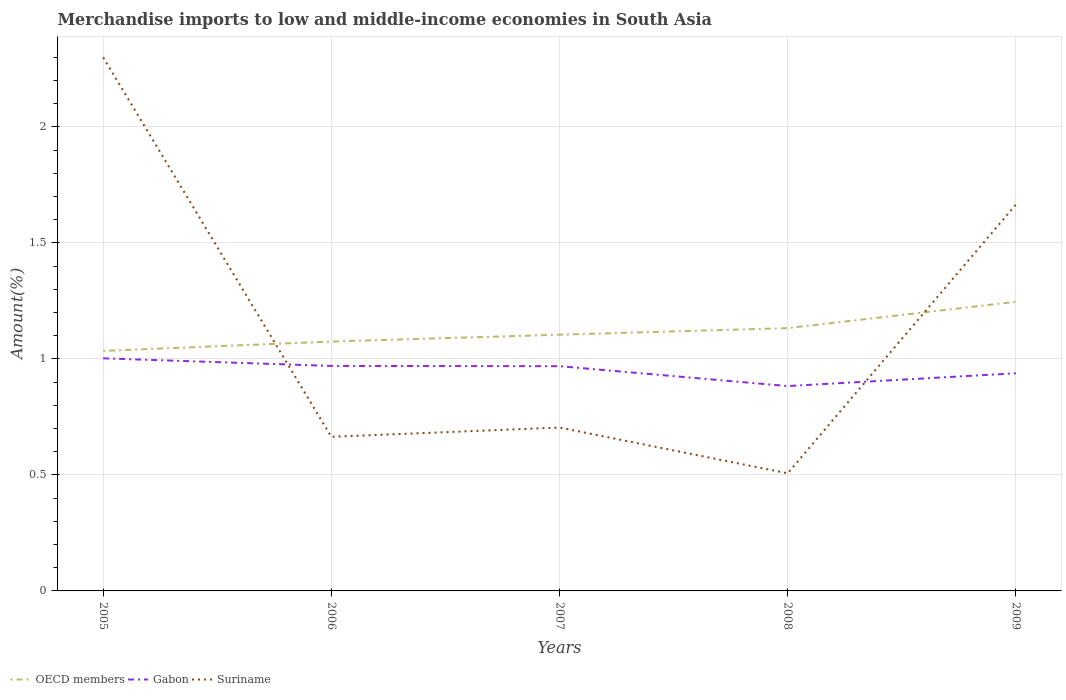How many different coloured lines are there?
Ensure brevity in your answer.  3. Does the line corresponding to Suriname intersect with the line corresponding to OECD members?
Offer a very short reply. Yes. Is the number of lines equal to the number of legend labels?
Provide a succinct answer. Yes. Across all years, what is the maximum percentage of amount earned from merchandise imports in OECD members?
Provide a short and direct response. 1.03. In which year was the percentage of amount earned from merchandise imports in Gabon maximum?
Provide a short and direct response. 2008. What is the total percentage of amount earned from merchandise imports in Suriname in the graph?
Provide a short and direct response. 0.16. What is the difference between the highest and the second highest percentage of amount earned from merchandise imports in Gabon?
Your response must be concise. 0.12. What is the difference between the highest and the lowest percentage of amount earned from merchandise imports in OECD members?
Make the answer very short. 2. Is the percentage of amount earned from merchandise imports in Gabon strictly greater than the percentage of amount earned from merchandise imports in OECD members over the years?
Your response must be concise. Yes. How many years are there in the graph?
Your answer should be very brief. 5. Does the graph contain any zero values?
Keep it short and to the point. No. Where does the legend appear in the graph?
Keep it short and to the point. Bottom left. How are the legend labels stacked?
Your response must be concise. Horizontal. What is the title of the graph?
Keep it short and to the point. Merchandise imports to low and middle-income economies in South Asia. What is the label or title of the X-axis?
Provide a short and direct response. Years. What is the label or title of the Y-axis?
Provide a short and direct response. Amount(%). What is the Amount(%) in OECD members in 2005?
Keep it short and to the point. 1.03. What is the Amount(%) in Gabon in 2005?
Make the answer very short. 1. What is the Amount(%) of Suriname in 2005?
Your answer should be very brief. 2.3. What is the Amount(%) of OECD members in 2006?
Ensure brevity in your answer.  1.07. What is the Amount(%) of Gabon in 2006?
Provide a short and direct response. 0.97. What is the Amount(%) in Suriname in 2006?
Keep it short and to the point. 0.66. What is the Amount(%) of OECD members in 2007?
Provide a succinct answer. 1.1. What is the Amount(%) of Gabon in 2007?
Keep it short and to the point. 0.97. What is the Amount(%) of Suriname in 2007?
Your answer should be very brief. 0.7. What is the Amount(%) in OECD members in 2008?
Make the answer very short. 1.13. What is the Amount(%) of Gabon in 2008?
Your answer should be very brief. 0.88. What is the Amount(%) in Suriname in 2008?
Give a very brief answer. 0.51. What is the Amount(%) in OECD members in 2009?
Offer a very short reply. 1.25. What is the Amount(%) of Gabon in 2009?
Provide a short and direct response. 0.94. What is the Amount(%) of Suriname in 2009?
Your answer should be compact. 1.67. Across all years, what is the maximum Amount(%) in OECD members?
Provide a succinct answer. 1.25. Across all years, what is the maximum Amount(%) in Gabon?
Provide a short and direct response. 1. Across all years, what is the maximum Amount(%) of Suriname?
Provide a short and direct response. 2.3. Across all years, what is the minimum Amount(%) of OECD members?
Give a very brief answer. 1.03. Across all years, what is the minimum Amount(%) in Gabon?
Provide a succinct answer. 0.88. Across all years, what is the minimum Amount(%) in Suriname?
Provide a succinct answer. 0.51. What is the total Amount(%) in OECD members in the graph?
Provide a succinct answer. 5.59. What is the total Amount(%) in Gabon in the graph?
Offer a terse response. 4.76. What is the total Amount(%) of Suriname in the graph?
Your answer should be compact. 5.84. What is the difference between the Amount(%) in OECD members in 2005 and that in 2006?
Provide a short and direct response. -0.04. What is the difference between the Amount(%) in Gabon in 2005 and that in 2006?
Offer a very short reply. 0.03. What is the difference between the Amount(%) of Suriname in 2005 and that in 2006?
Your answer should be compact. 1.64. What is the difference between the Amount(%) of OECD members in 2005 and that in 2007?
Your answer should be compact. -0.07. What is the difference between the Amount(%) in Gabon in 2005 and that in 2007?
Your answer should be very brief. 0.03. What is the difference between the Amount(%) in Suriname in 2005 and that in 2007?
Ensure brevity in your answer.  1.6. What is the difference between the Amount(%) of OECD members in 2005 and that in 2008?
Your answer should be very brief. -0.1. What is the difference between the Amount(%) of Gabon in 2005 and that in 2008?
Provide a succinct answer. 0.12. What is the difference between the Amount(%) of Suriname in 2005 and that in 2008?
Provide a short and direct response. 1.79. What is the difference between the Amount(%) in OECD members in 2005 and that in 2009?
Give a very brief answer. -0.21. What is the difference between the Amount(%) in Gabon in 2005 and that in 2009?
Ensure brevity in your answer.  0.06. What is the difference between the Amount(%) of Suriname in 2005 and that in 2009?
Offer a very short reply. 0.63. What is the difference between the Amount(%) in OECD members in 2006 and that in 2007?
Your answer should be compact. -0.03. What is the difference between the Amount(%) of Gabon in 2006 and that in 2007?
Make the answer very short. 0. What is the difference between the Amount(%) of Suriname in 2006 and that in 2007?
Give a very brief answer. -0.04. What is the difference between the Amount(%) in OECD members in 2006 and that in 2008?
Your answer should be compact. -0.06. What is the difference between the Amount(%) of Gabon in 2006 and that in 2008?
Keep it short and to the point. 0.09. What is the difference between the Amount(%) in Suriname in 2006 and that in 2008?
Your response must be concise. 0.16. What is the difference between the Amount(%) in OECD members in 2006 and that in 2009?
Your answer should be compact. -0.17. What is the difference between the Amount(%) of Gabon in 2006 and that in 2009?
Your answer should be very brief. 0.03. What is the difference between the Amount(%) of Suriname in 2006 and that in 2009?
Ensure brevity in your answer.  -1. What is the difference between the Amount(%) of OECD members in 2007 and that in 2008?
Your answer should be compact. -0.03. What is the difference between the Amount(%) in Gabon in 2007 and that in 2008?
Your answer should be compact. 0.09. What is the difference between the Amount(%) of Suriname in 2007 and that in 2008?
Your answer should be very brief. 0.2. What is the difference between the Amount(%) in OECD members in 2007 and that in 2009?
Offer a very short reply. -0.14. What is the difference between the Amount(%) in Gabon in 2007 and that in 2009?
Keep it short and to the point. 0.03. What is the difference between the Amount(%) of Suriname in 2007 and that in 2009?
Your answer should be compact. -0.96. What is the difference between the Amount(%) in OECD members in 2008 and that in 2009?
Give a very brief answer. -0.11. What is the difference between the Amount(%) in Gabon in 2008 and that in 2009?
Give a very brief answer. -0.06. What is the difference between the Amount(%) of Suriname in 2008 and that in 2009?
Give a very brief answer. -1.16. What is the difference between the Amount(%) in OECD members in 2005 and the Amount(%) in Gabon in 2006?
Offer a terse response. 0.06. What is the difference between the Amount(%) of OECD members in 2005 and the Amount(%) of Suriname in 2006?
Provide a succinct answer. 0.37. What is the difference between the Amount(%) of Gabon in 2005 and the Amount(%) of Suriname in 2006?
Your answer should be compact. 0.34. What is the difference between the Amount(%) of OECD members in 2005 and the Amount(%) of Gabon in 2007?
Offer a terse response. 0.07. What is the difference between the Amount(%) of OECD members in 2005 and the Amount(%) of Suriname in 2007?
Offer a terse response. 0.33. What is the difference between the Amount(%) in Gabon in 2005 and the Amount(%) in Suriname in 2007?
Provide a succinct answer. 0.3. What is the difference between the Amount(%) of OECD members in 2005 and the Amount(%) of Gabon in 2008?
Your response must be concise. 0.15. What is the difference between the Amount(%) in OECD members in 2005 and the Amount(%) in Suriname in 2008?
Offer a very short reply. 0.53. What is the difference between the Amount(%) in Gabon in 2005 and the Amount(%) in Suriname in 2008?
Provide a succinct answer. 0.5. What is the difference between the Amount(%) in OECD members in 2005 and the Amount(%) in Gabon in 2009?
Your answer should be very brief. 0.1. What is the difference between the Amount(%) in OECD members in 2005 and the Amount(%) in Suriname in 2009?
Offer a very short reply. -0.63. What is the difference between the Amount(%) of Gabon in 2005 and the Amount(%) of Suriname in 2009?
Your response must be concise. -0.66. What is the difference between the Amount(%) in OECD members in 2006 and the Amount(%) in Gabon in 2007?
Your response must be concise. 0.11. What is the difference between the Amount(%) in OECD members in 2006 and the Amount(%) in Suriname in 2007?
Ensure brevity in your answer.  0.37. What is the difference between the Amount(%) of Gabon in 2006 and the Amount(%) of Suriname in 2007?
Provide a short and direct response. 0.27. What is the difference between the Amount(%) of OECD members in 2006 and the Amount(%) of Gabon in 2008?
Ensure brevity in your answer.  0.19. What is the difference between the Amount(%) of OECD members in 2006 and the Amount(%) of Suriname in 2008?
Offer a terse response. 0.57. What is the difference between the Amount(%) of Gabon in 2006 and the Amount(%) of Suriname in 2008?
Ensure brevity in your answer.  0.46. What is the difference between the Amount(%) in OECD members in 2006 and the Amount(%) in Gabon in 2009?
Provide a short and direct response. 0.14. What is the difference between the Amount(%) in OECD members in 2006 and the Amount(%) in Suriname in 2009?
Your answer should be very brief. -0.59. What is the difference between the Amount(%) of Gabon in 2006 and the Amount(%) of Suriname in 2009?
Your answer should be compact. -0.7. What is the difference between the Amount(%) in OECD members in 2007 and the Amount(%) in Gabon in 2008?
Give a very brief answer. 0.22. What is the difference between the Amount(%) of OECD members in 2007 and the Amount(%) of Suriname in 2008?
Offer a terse response. 0.6. What is the difference between the Amount(%) in Gabon in 2007 and the Amount(%) in Suriname in 2008?
Your answer should be very brief. 0.46. What is the difference between the Amount(%) of OECD members in 2007 and the Amount(%) of Gabon in 2009?
Make the answer very short. 0.17. What is the difference between the Amount(%) of OECD members in 2007 and the Amount(%) of Suriname in 2009?
Offer a very short reply. -0.56. What is the difference between the Amount(%) in Gabon in 2007 and the Amount(%) in Suriname in 2009?
Give a very brief answer. -0.7. What is the difference between the Amount(%) of OECD members in 2008 and the Amount(%) of Gabon in 2009?
Provide a short and direct response. 0.19. What is the difference between the Amount(%) in OECD members in 2008 and the Amount(%) in Suriname in 2009?
Ensure brevity in your answer.  -0.53. What is the difference between the Amount(%) in Gabon in 2008 and the Amount(%) in Suriname in 2009?
Keep it short and to the point. -0.78. What is the average Amount(%) in OECD members per year?
Give a very brief answer. 1.12. What is the average Amount(%) of Gabon per year?
Provide a short and direct response. 0.95. What is the average Amount(%) of Suriname per year?
Your response must be concise. 1.17. In the year 2005, what is the difference between the Amount(%) in OECD members and Amount(%) in Gabon?
Ensure brevity in your answer.  0.03. In the year 2005, what is the difference between the Amount(%) in OECD members and Amount(%) in Suriname?
Offer a terse response. -1.26. In the year 2005, what is the difference between the Amount(%) in Gabon and Amount(%) in Suriname?
Offer a very short reply. -1.3. In the year 2006, what is the difference between the Amount(%) of OECD members and Amount(%) of Gabon?
Make the answer very short. 0.11. In the year 2006, what is the difference between the Amount(%) in OECD members and Amount(%) in Suriname?
Provide a succinct answer. 0.41. In the year 2006, what is the difference between the Amount(%) in Gabon and Amount(%) in Suriname?
Your answer should be very brief. 0.31. In the year 2007, what is the difference between the Amount(%) in OECD members and Amount(%) in Gabon?
Your response must be concise. 0.14. In the year 2007, what is the difference between the Amount(%) of OECD members and Amount(%) of Suriname?
Your response must be concise. 0.4. In the year 2007, what is the difference between the Amount(%) of Gabon and Amount(%) of Suriname?
Make the answer very short. 0.26. In the year 2008, what is the difference between the Amount(%) in OECD members and Amount(%) in Gabon?
Offer a terse response. 0.25. In the year 2008, what is the difference between the Amount(%) in OECD members and Amount(%) in Suriname?
Give a very brief answer. 0.63. In the year 2008, what is the difference between the Amount(%) in Gabon and Amount(%) in Suriname?
Provide a succinct answer. 0.38. In the year 2009, what is the difference between the Amount(%) in OECD members and Amount(%) in Gabon?
Provide a succinct answer. 0.31. In the year 2009, what is the difference between the Amount(%) in OECD members and Amount(%) in Suriname?
Ensure brevity in your answer.  -0.42. In the year 2009, what is the difference between the Amount(%) of Gabon and Amount(%) of Suriname?
Your response must be concise. -0.73. What is the ratio of the Amount(%) in OECD members in 2005 to that in 2006?
Ensure brevity in your answer.  0.96. What is the ratio of the Amount(%) of Gabon in 2005 to that in 2006?
Provide a succinct answer. 1.03. What is the ratio of the Amount(%) of Suriname in 2005 to that in 2006?
Make the answer very short. 3.46. What is the ratio of the Amount(%) in OECD members in 2005 to that in 2007?
Offer a terse response. 0.94. What is the ratio of the Amount(%) of Gabon in 2005 to that in 2007?
Make the answer very short. 1.03. What is the ratio of the Amount(%) of Suriname in 2005 to that in 2007?
Make the answer very short. 3.27. What is the ratio of the Amount(%) of OECD members in 2005 to that in 2008?
Ensure brevity in your answer.  0.91. What is the ratio of the Amount(%) of Gabon in 2005 to that in 2008?
Give a very brief answer. 1.14. What is the ratio of the Amount(%) in Suriname in 2005 to that in 2008?
Keep it short and to the point. 4.54. What is the ratio of the Amount(%) of OECD members in 2005 to that in 2009?
Offer a terse response. 0.83. What is the ratio of the Amount(%) of Gabon in 2005 to that in 2009?
Your answer should be very brief. 1.07. What is the ratio of the Amount(%) of Suriname in 2005 to that in 2009?
Provide a succinct answer. 1.38. What is the ratio of the Amount(%) in OECD members in 2006 to that in 2007?
Provide a succinct answer. 0.97. What is the ratio of the Amount(%) of Suriname in 2006 to that in 2007?
Provide a short and direct response. 0.94. What is the ratio of the Amount(%) of OECD members in 2006 to that in 2008?
Keep it short and to the point. 0.95. What is the ratio of the Amount(%) of Gabon in 2006 to that in 2008?
Keep it short and to the point. 1.1. What is the ratio of the Amount(%) in Suriname in 2006 to that in 2008?
Provide a succinct answer. 1.31. What is the ratio of the Amount(%) of OECD members in 2006 to that in 2009?
Make the answer very short. 0.86. What is the ratio of the Amount(%) in Gabon in 2006 to that in 2009?
Your answer should be compact. 1.03. What is the ratio of the Amount(%) in Suriname in 2006 to that in 2009?
Ensure brevity in your answer.  0.4. What is the ratio of the Amount(%) in OECD members in 2007 to that in 2008?
Provide a short and direct response. 0.97. What is the ratio of the Amount(%) of Gabon in 2007 to that in 2008?
Provide a succinct answer. 1.1. What is the ratio of the Amount(%) of Suriname in 2007 to that in 2008?
Ensure brevity in your answer.  1.39. What is the ratio of the Amount(%) of OECD members in 2007 to that in 2009?
Keep it short and to the point. 0.89. What is the ratio of the Amount(%) of Gabon in 2007 to that in 2009?
Provide a succinct answer. 1.03. What is the ratio of the Amount(%) in Suriname in 2007 to that in 2009?
Offer a terse response. 0.42. What is the ratio of the Amount(%) of OECD members in 2008 to that in 2009?
Make the answer very short. 0.91. What is the ratio of the Amount(%) in Gabon in 2008 to that in 2009?
Give a very brief answer. 0.94. What is the ratio of the Amount(%) of Suriname in 2008 to that in 2009?
Provide a short and direct response. 0.3. What is the difference between the highest and the second highest Amount(%) in OECD members?
Ensure brevity in your answer.  0.11. What is the difference between the highest and the second highest Amount(%) of Gabon?
Your answer should be compact. 0.03. What is the difference between the highest and the second highest Amount(%) of Suriname?
Provide a short and direct response. 0.63. What is the difference between the highest and the lowest Amount(%) in OECD members?
Make the answer very short. 0.21. What is the difference between the highest and the lowest Amount(%) of Gabon?
Keep it short and to the point. 0.12. What is the difference between the highest and the lowest Amount(%) in Suriname?
Give a very brief answer. 1.79. 